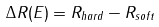<formula> <loc_0><loc_0><loc_500><loc_500>\Delta R ( E ) = R _ { h a r d } - R _ { s o f t }</formula> 